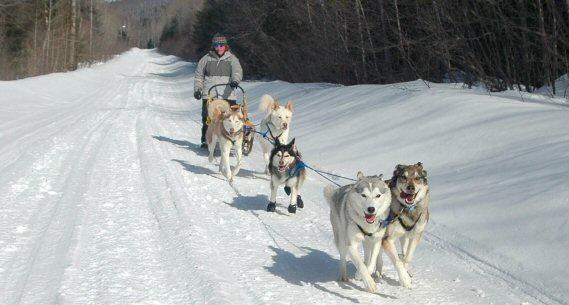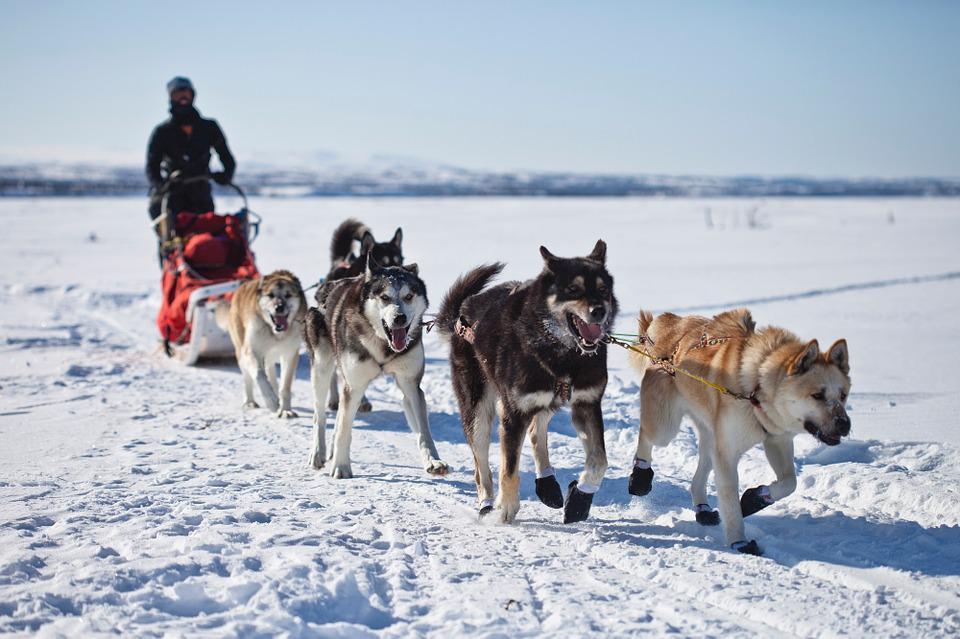The first image is the image on the left, the second image is the image on the right. Evaluate the accuracy of this statement regarding the images: "In one image a team of sled dogs are pulling a person to the left.". Is it true? Answer yes or no. No. 